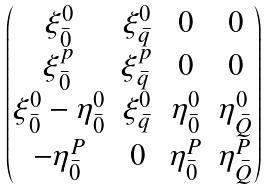Convert formula to latex. <formula><loc_0><loc_0><loc_500><loc_500>\begin{pmatrix} \xi ^ { 0 } _ { \bar { 0 } } & \xi ^ { 0 } _ { \bar { q } } & 0 & 0 \\ \xi ^ { p } _ { \bar { 0 } } & \xi ^ { p } _ { \bar { q } } & 0 & 0 \\ \xi ^ { 0 } _ { \bar { 0 } } - \eta ^ { 0 } _ { \bar { 0 } } & \xi ^ { 0 } _ { \bar { q } } & \eta ^ { 0 } _ { \bar { 0 } } & \eta ^ { 0 } _ { \bar { Q } } \\ - \eta ^ { P } _ { \bar { 0 } } & 0 & \eta ^ { P } _ { \bar { 0 } } & \eta ^ { P } _ { \bar { Q } } \end{pmatrix}</formula> 